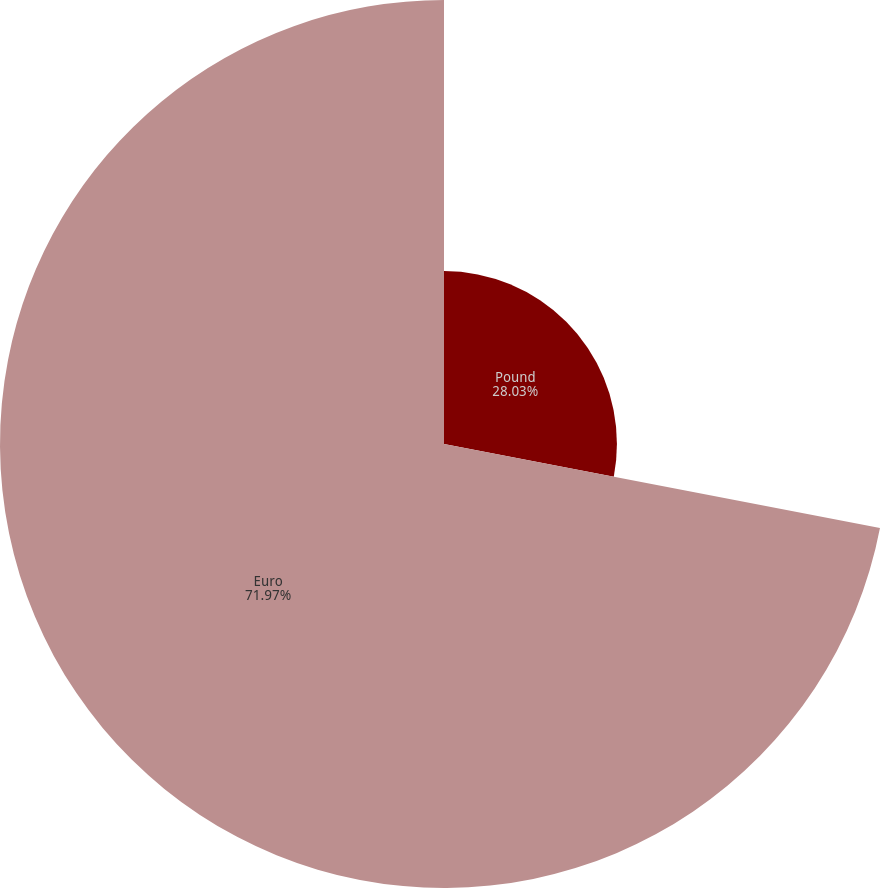<chart> <loc_0><loc_0><loc_500><loc_500><pie_chart><fcel>Pound<fcel>Euro<nl><fcel>28.03%<fcel>71.97%<nl></chart> 